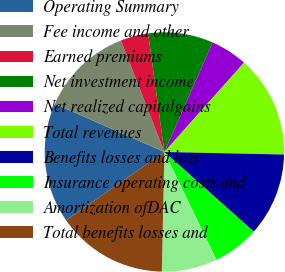<chart> <loc_0><loc_0><loc_500><loc_500><pie_chart><fcel>Operating Summary<fcel>Fee income and other<fcel>Earned premiums<fcel>Net investment income<fcel>Net realized capitalgains<fcel>Total revenues<fcel>Benefits losses and loss<fcel>Insurance operating costs and<fcel>Amortization ofDAC<fcel>Total benefits losses and<nl><fcel>16.25%<fcel>12.5%<fcel>3.75%<fcel>8.75%<fcel>5.0%<fcel>13.75%<fcel>11.25%<fcel>6.25%<fcel>7.5%<fcel>15.0%<nl></chart> 